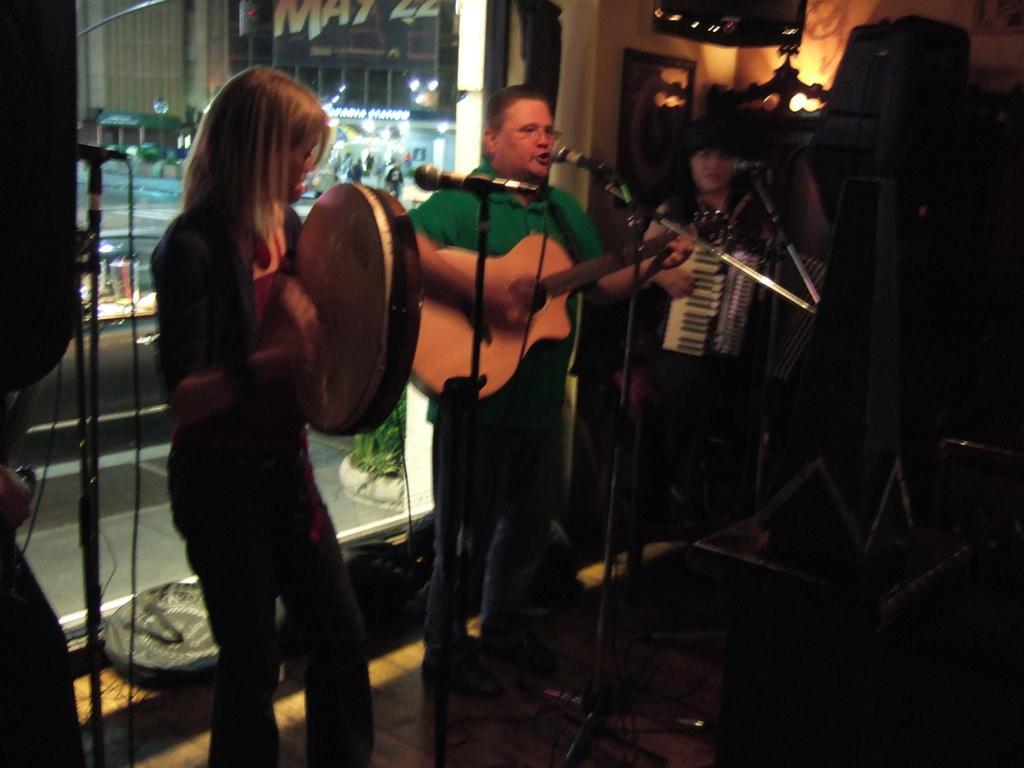Describe this image in one or two sentences. In the foreground of this image, there are persons standing and playing musical instruments in front of mics in a dark room and on the top right, there is a light and few objects. On the left, through the glass, there are buildings, lights, plants and the path. 